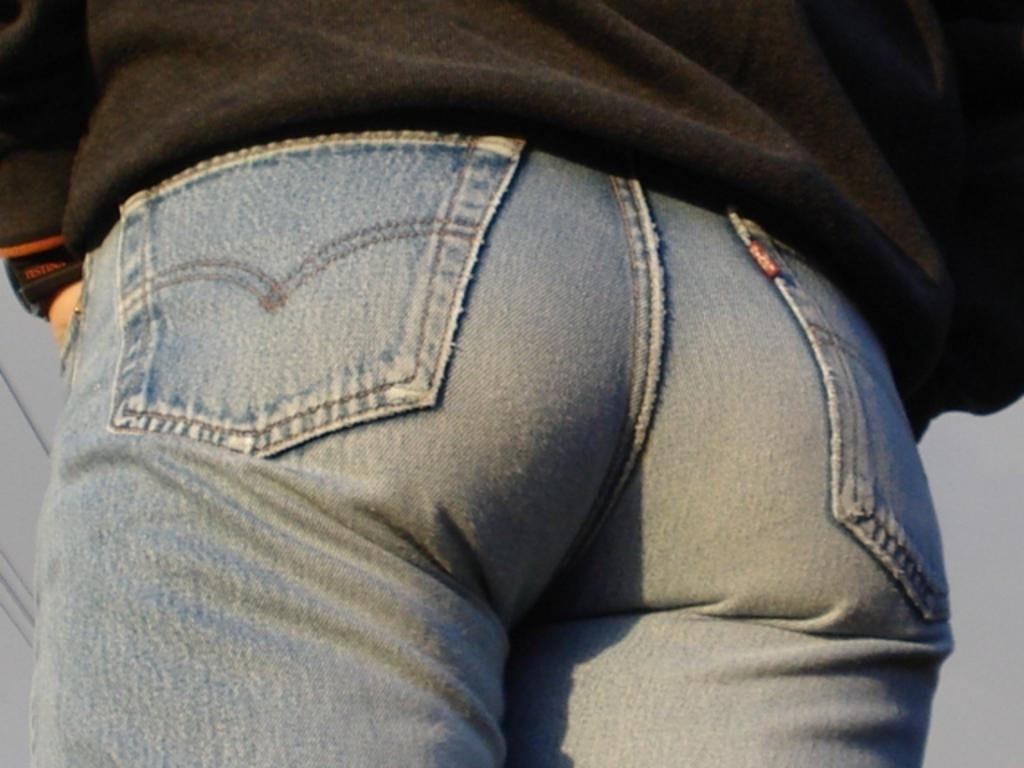Who or what is present in the image? There is a person in the image. What type of clothing is the person wearing? The person is wearing jeans. What can be seen in the background of the image? There is a sky visible in the background of the image. What is located on the left side of the image? There are wires on the left side of the image. What sense does the person in the image lack? There is no information provided about the person's senses, so we cannot determine if they lack any sense. What role does the servant play in the image? There is no servant present in the image. 